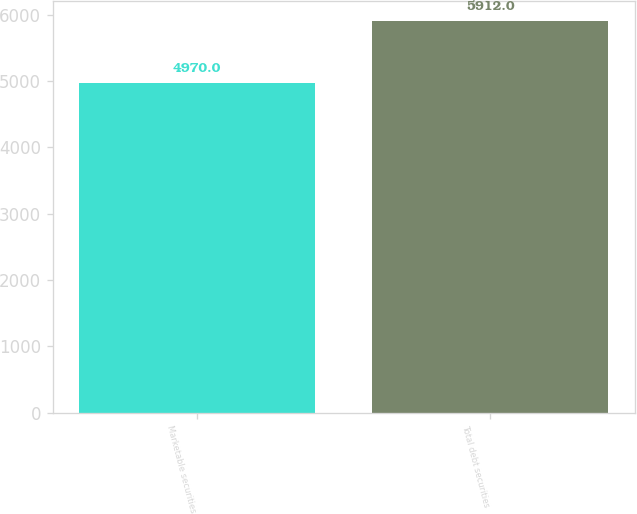Convert chart to OTSL. <chart><loc_0><loc_0><loc_500><loc_500><bar_chart><fcel>Marketable securities<fcel>Total debt securities<nl><fcel>4970<fcel>5912<nl></chart> 